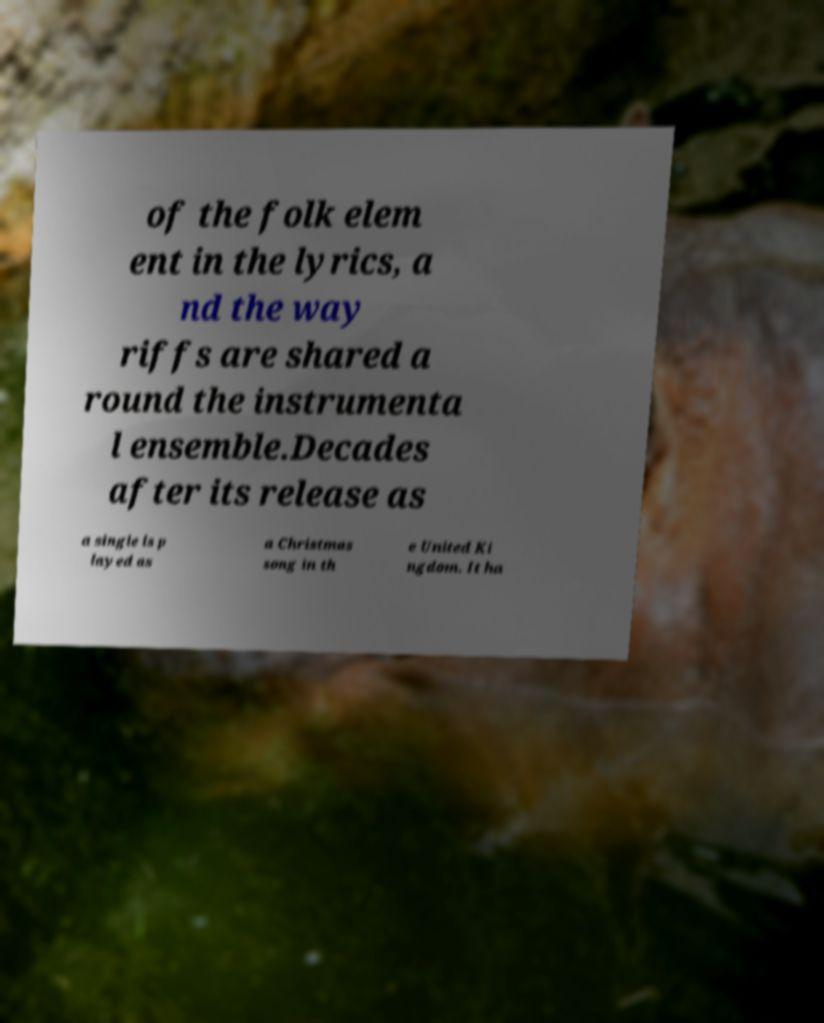Please identify and transcribe the text found in this image. of the folk elem ent in the lyrics, a nd the way riffs are shared a round the instrumenta l ensemble.Decades after its release as a single is p layed as a Christmas song in th e United Ki ngdom. It ha 